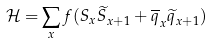Convert formula to latex. <formula><loc_0><loc_0><loc_500><loc_500>\mathcal { H = } \sum _ { x } f ( S _ { x } \widetilde { S } _ { x + 1 } + \overline { q } _ { x } \widetilde { q } _ { x + 1 } )</formula> 